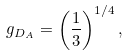<formula> <loc_0><loc_0><loc_500><loc_500>g _ { D _ { A } } = \left ( \frac { 1 } { 3 } \right ) ^ { 1 / 4 } ,</formula> 